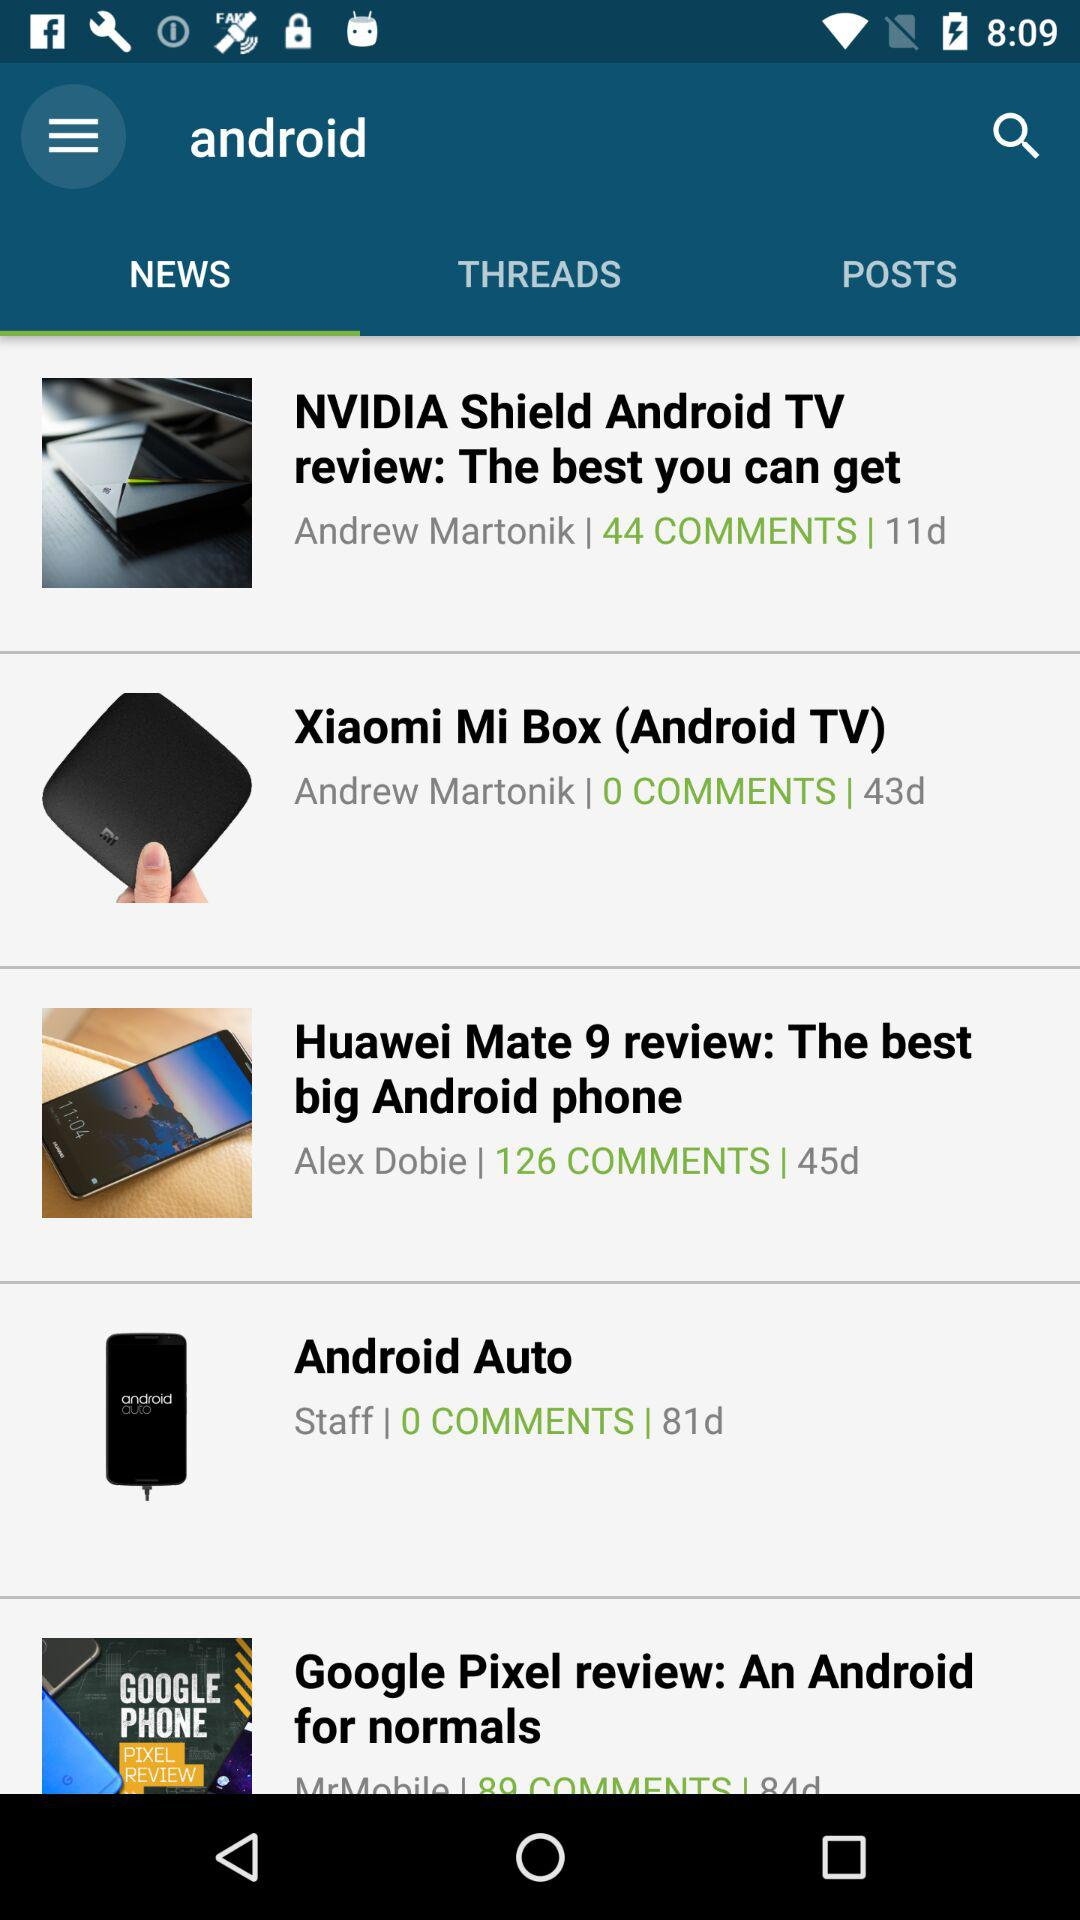Which tab is selected? The selected tab is "NEWS". 